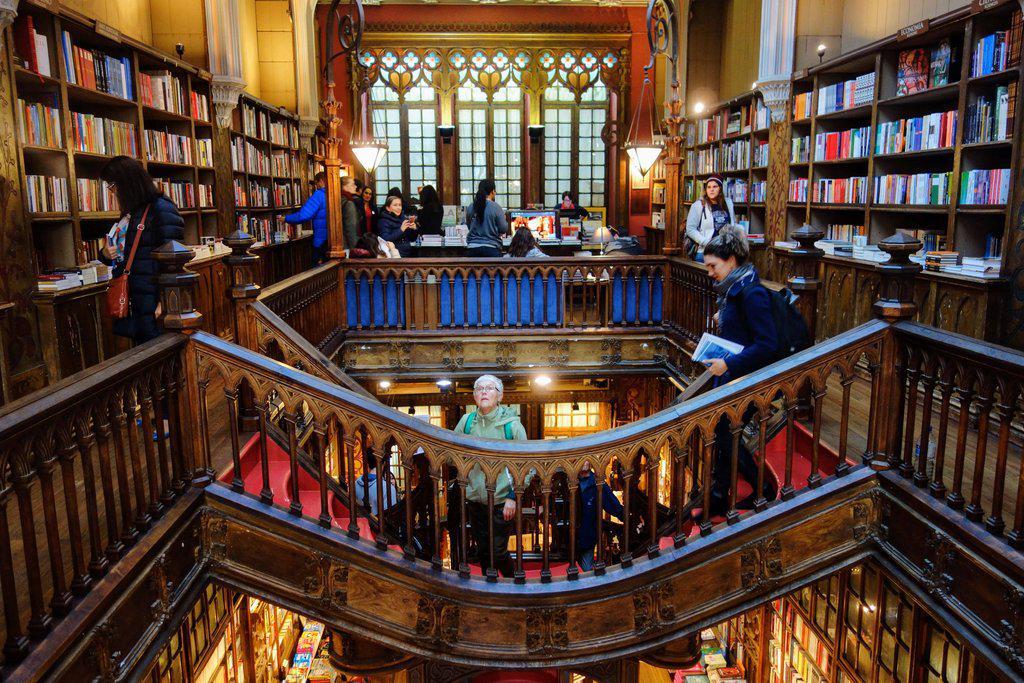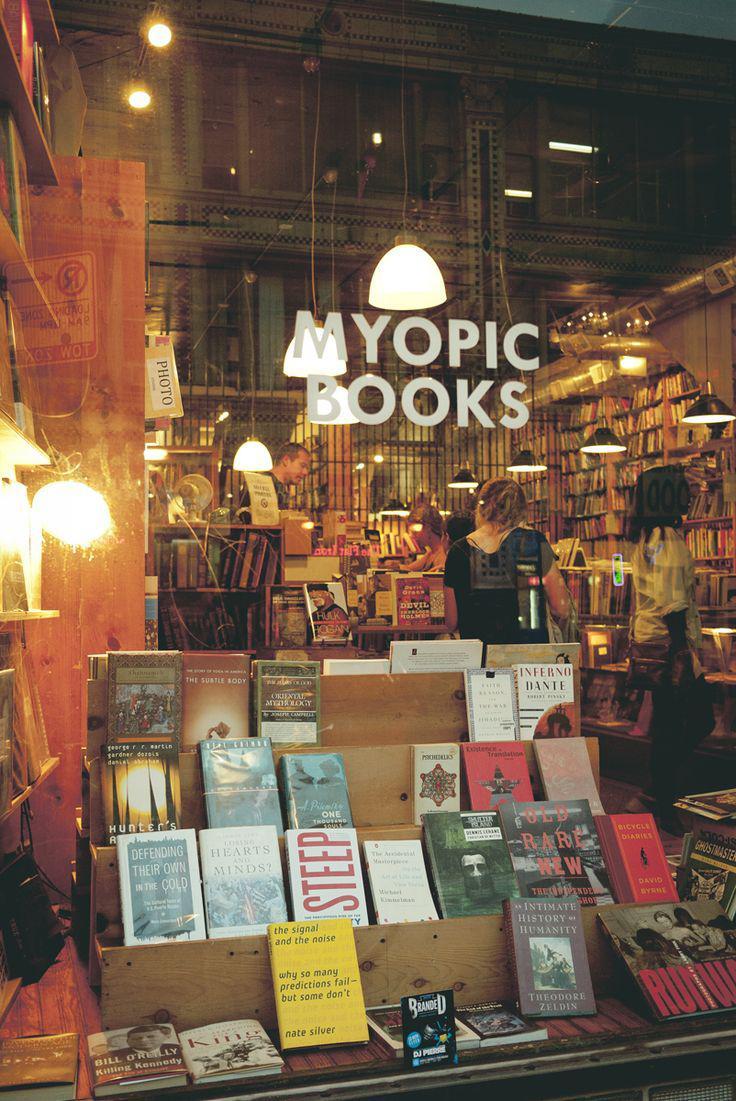The first image is the image on the left, the second image is the image on the right. Assess this claim about the two images: "There is a stairway visible in one of the images.". Correct or not? Answer yes or no. Yes. The first image is the image on the left, the second image is the image on the right. Examine the images to the left and right. Is the description "The left image shows a bookstore with a second floor of bookshelves surrounded by balcony rails." accurate? Answer yes or no. Yes. 